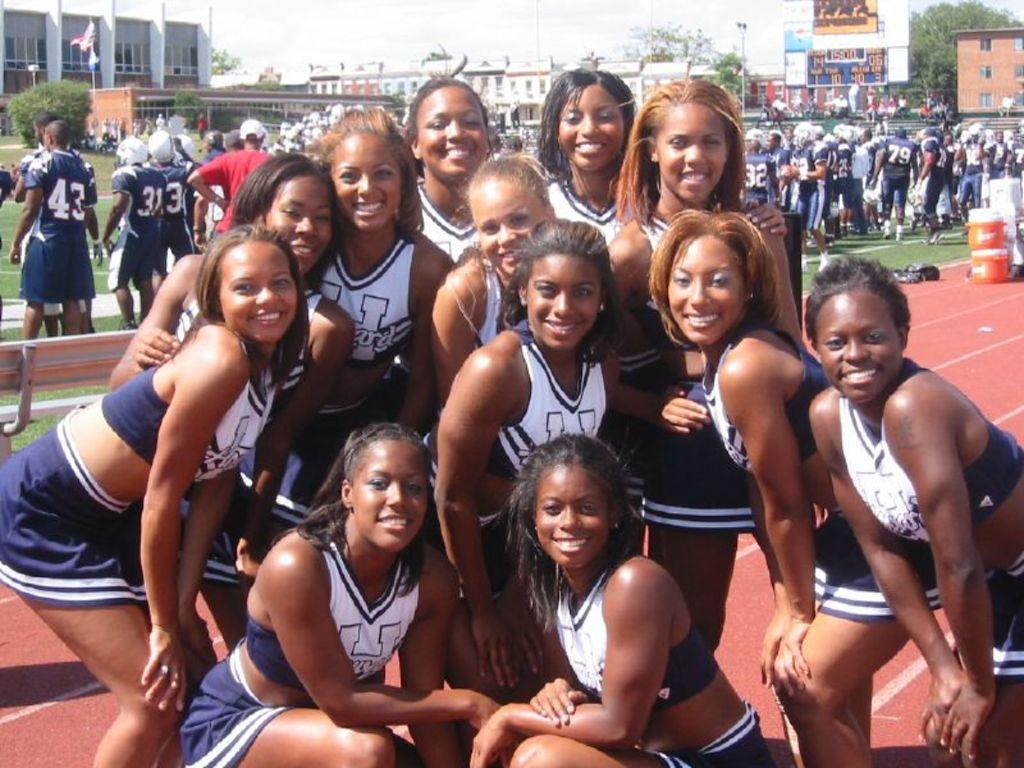Describe this image in one or two sentences. In this image we can see few women. In the background there are many people, trees, buildings, poles, flag poles, objects, bench, boxes and the sky. 